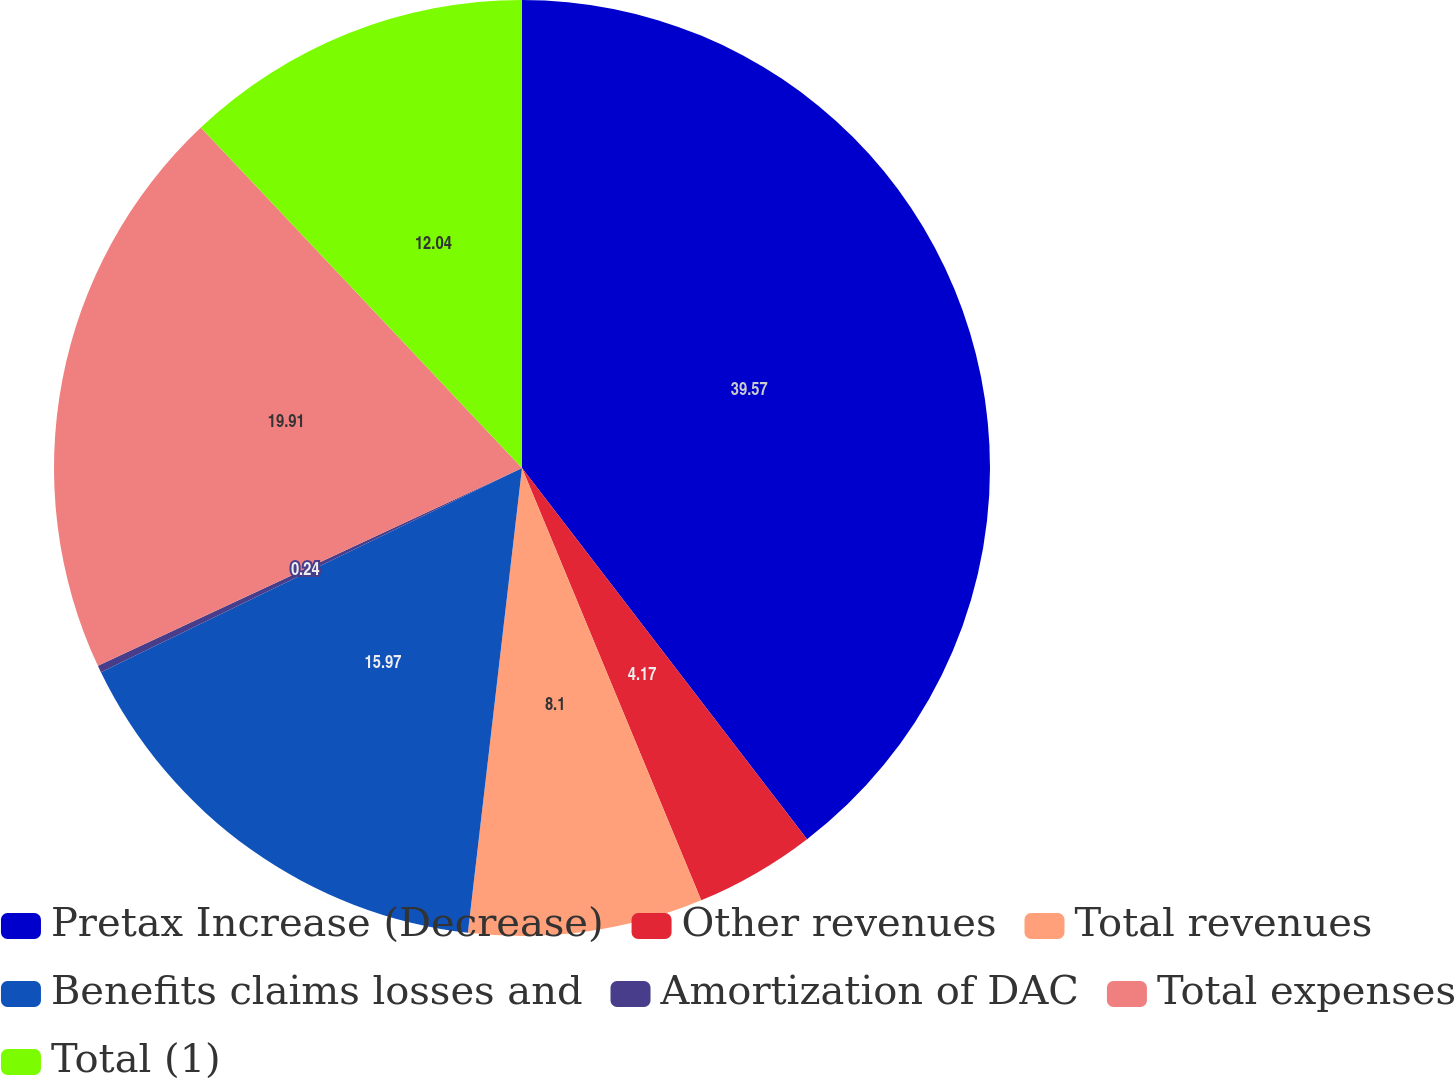Convert chart. <chart><loc_0><loc_0><loc_500><loc_500><pie_chart><fcel>Pretax Increase (Decrease)<fcel>Other revenues<fcel>Total revenues<fcel>Benefits claims losses and<fcel>Amortization of DAC<fcel>Total expenses<fcel>Total (1)<nl><fcel>39.58%<fcel>4.17%<fcel>8.1%<fcel>15.97%<fcel>0.24%<fcel>19.91%<fcel>12.04%<nl></chart> 